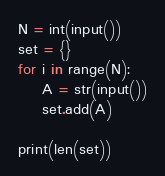<code> <loc_0><loc_0><loc_500><loc_500><_Python_>N = int(input())
set = {}
for i in range(N):
    A = str(input())
    set.add(A)

print(len(set))
</code> 